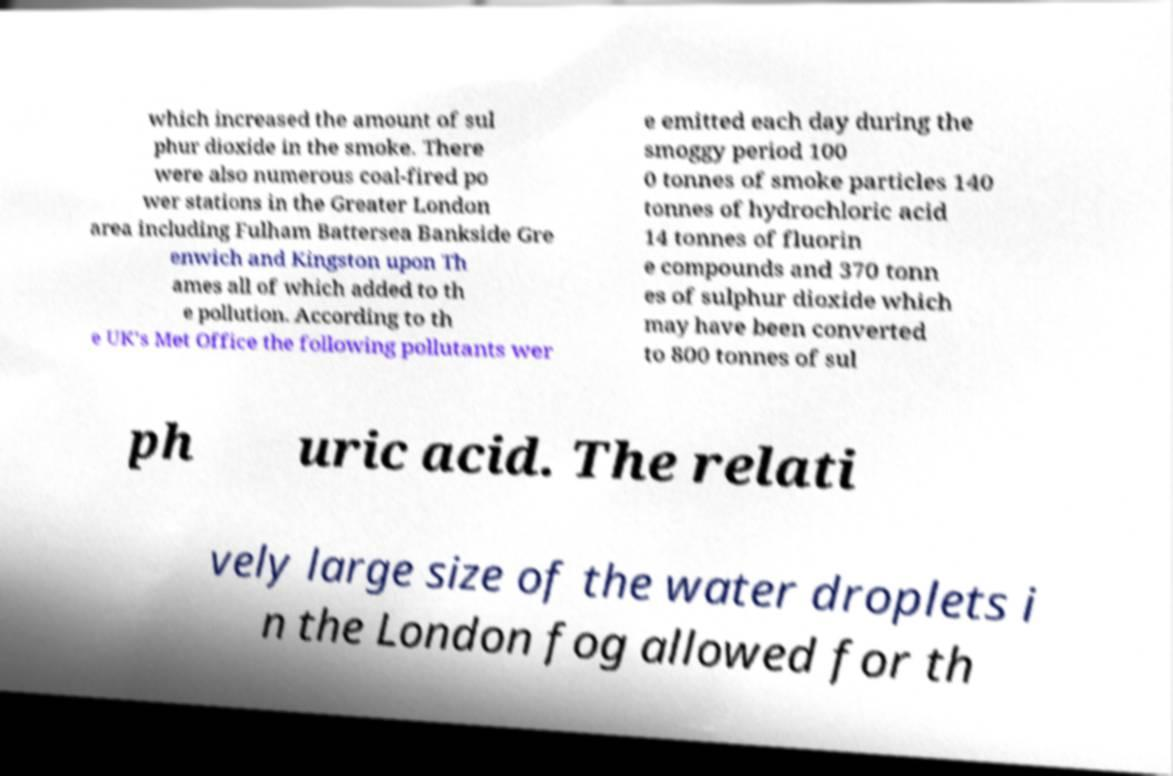Please read and relay the text visible in this image. What does it say? which increased the amount of sul phur dioxide in the smoke. There were also numerous coal-fired po wer stations in the Greater London area including Fulham Battersea Bankside Gre enwich and Kingston upon Th ames all of which added to th e pollution. According to th e UK's Met Office the following pollutants wer e emitted each day during the smoggy period 100 0 tonnes of smoke particles 140 tonnes of hydrochloric acid 14 tonnes of fluorin e compounds and 370 tonn es of sulphur dioxide which may have been converted to 800 tonnes of sul ph uric acid. The relati vely large size of the water droplets i n the London fog allowed for th 